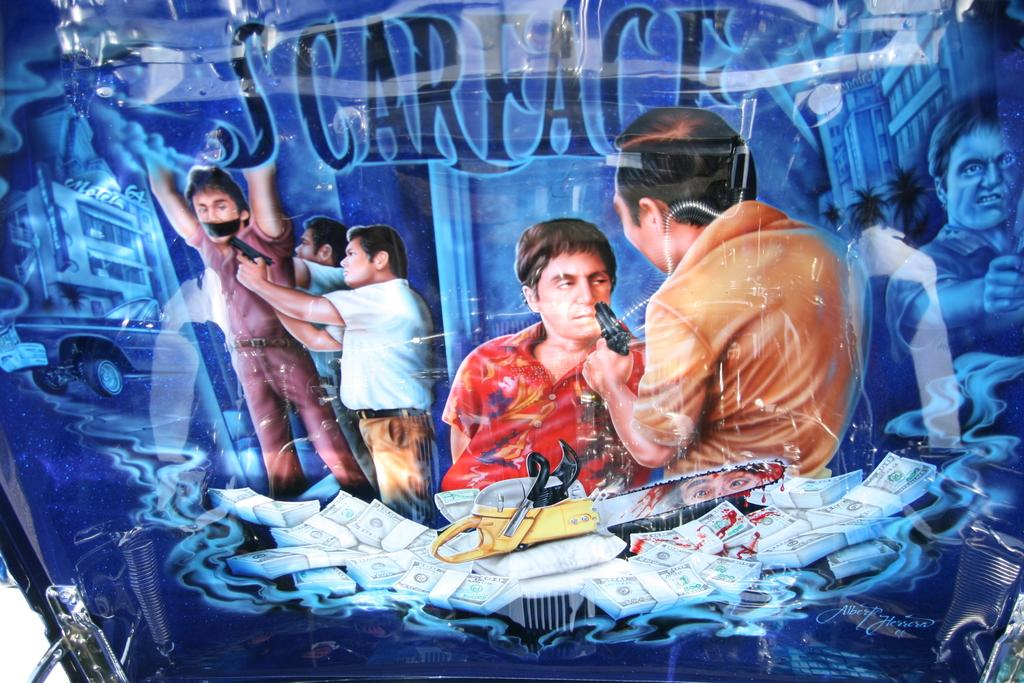What is the main subject of the image? There is a poster in the image. What can be seen on the poster? The poster contains images of people. What are the people in the poster doing? The people in the poster are standing and holding weapons. What type of theory is being discussed by the people in the poster? There is no discussion or theory present in the image; it only shows images of people standing and holding weapons. 